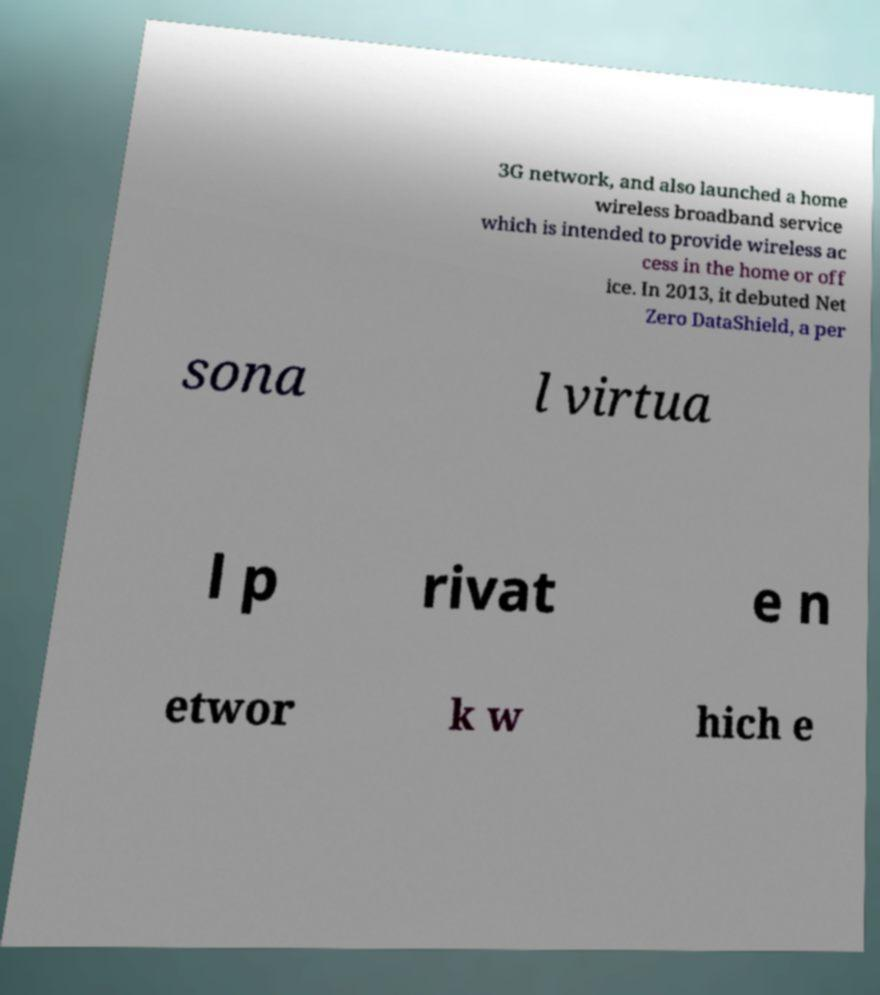I need the written content from this picture converted into text. Can you do that? 3G network, and also launched a home wireless broadband service which is intended to provide wireless ac cess in the home or off ice. In 2013, it debuted Net Zero DataShield, a per sona l virtua l p rivat e n etwor k w hich e 